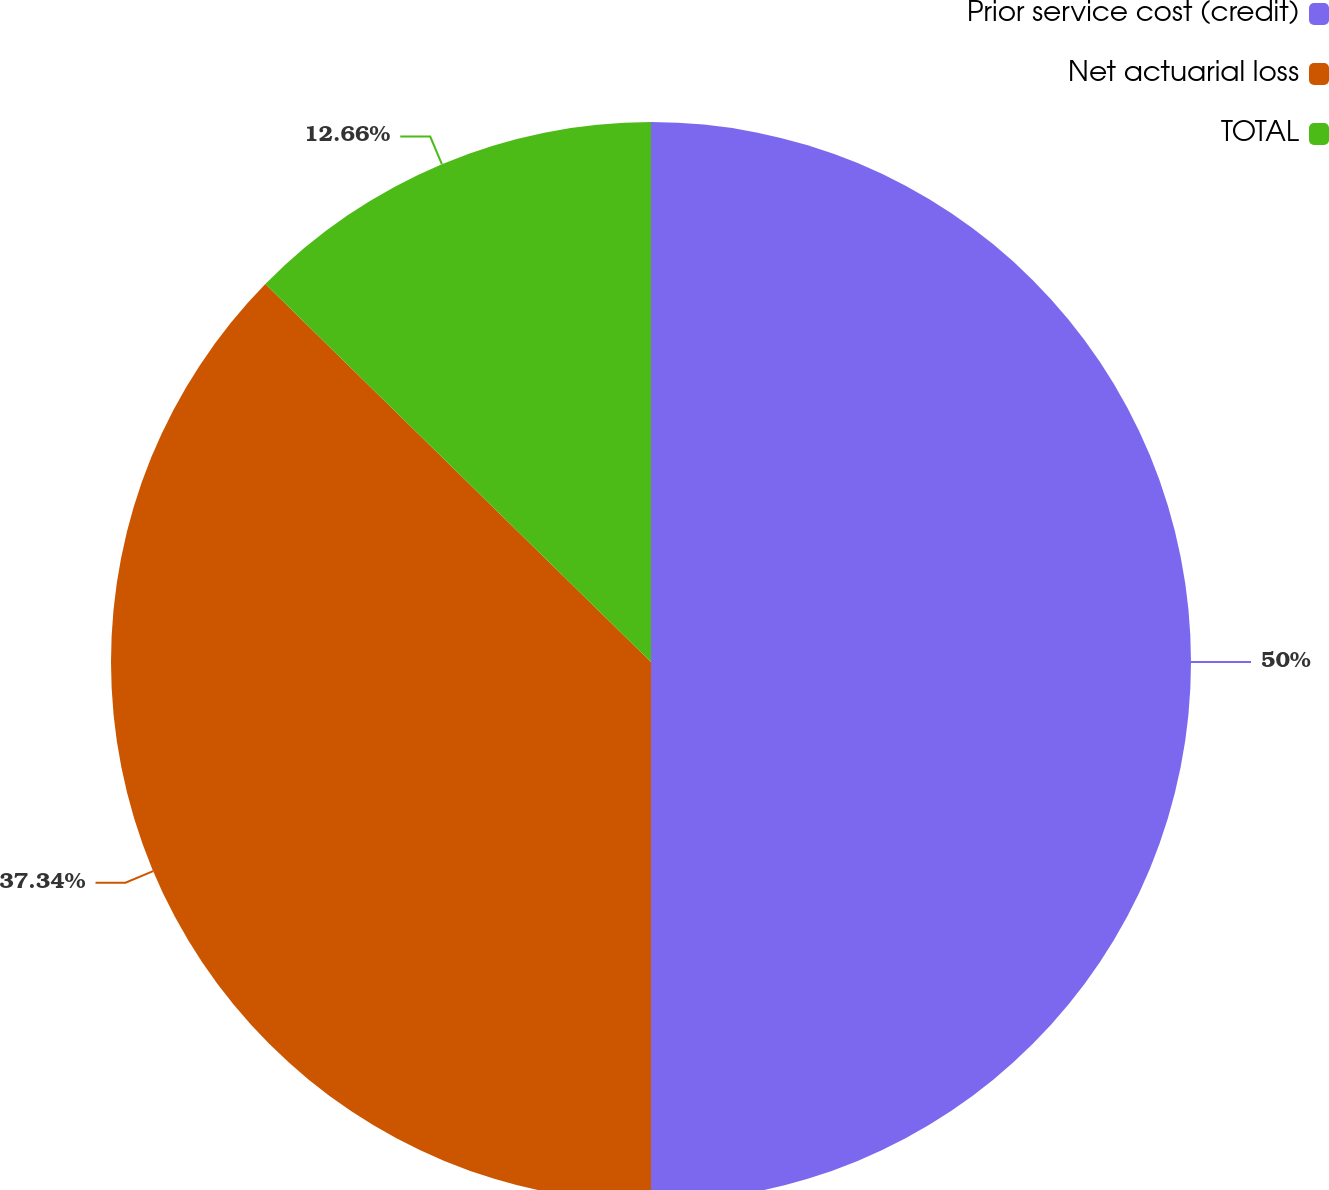Convert chart. <chart><loc_0><loc_0><loc_500><loc_500><pie_chart><fcel>Prior service cost (credit)<fcel>Net actuarial loss<fcel>TOTAL<nl><fcel>50.0%<fcel>37.34%<fcel>12.66%<nl></chart> 